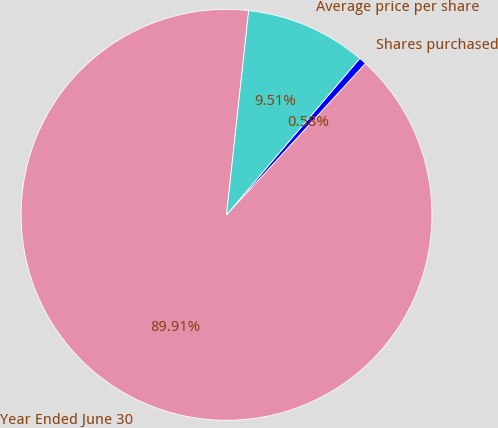<chart> <loc_0><loc_0><loc_500><loc_500><pie_chart><fcel>Year Ended June 30<fcel>Shares purchased<fcel>Average price per share<nl><fcel>89.91%<fcel>0.58%<fcel>9.51%<nl></chart> 